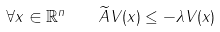Convert formula to latex. <formula><loc_0><loc_0><loc_500><loc_500>\forall x \in \mathbb { R } ^ { n } \quad \widetilde { A } V ( x ) \leq - \lambda V ( x )</formula> 